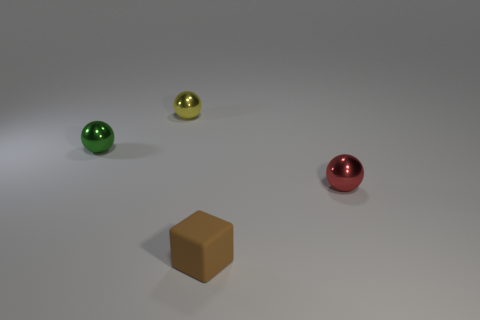Add 1 brown rubber blocks. How many objects exist? 5 Subtract all cubes. How many objects are left? 3 Subtract all tiny green shiny balls. How many balls are left? 2 Subtract all yellow balls. How many balls are left? 2 Subtract 1 green spheres. How many objects are left? 3 Subtract 2 balls. How many balls are left? 1 Subtract all gray blocks. Subtract all blue balls. How many blocks are left? 1 Subtract all red cubes. How many red balls are left? 1 Subtract all tiny things. Subtract all large blue metal objects. How many objects are left? 0 Add 2 green spheres. How many green spheres are left? 3 